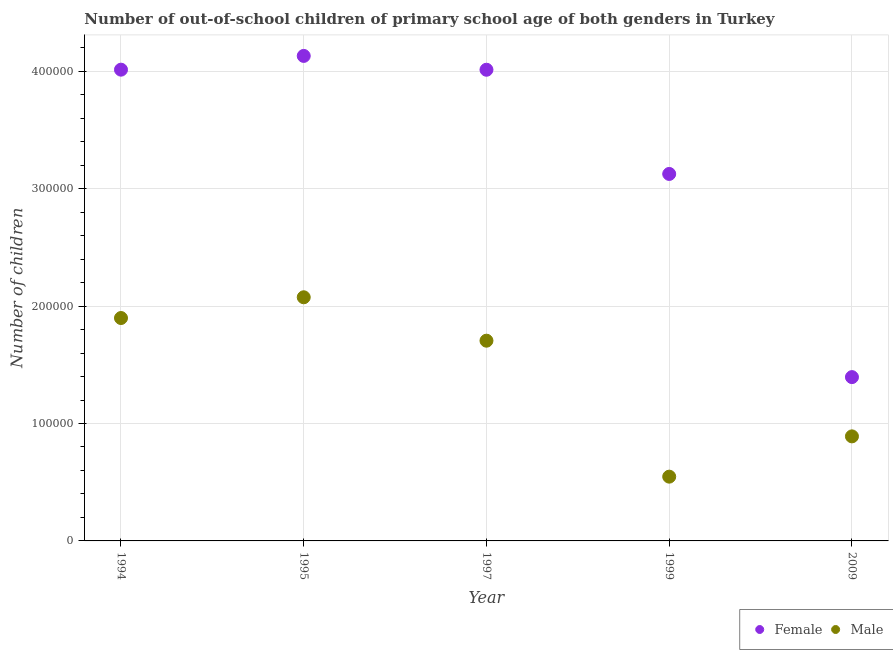Is the number of dotlines equal to the number of legend labels?
Your answer should be compact. Yes. What is the number of male out-of-school students in 1997?
Your answer should be compact. 1.71e+05. Across all years, what is the maximum number of male out-of-school students?
Your answer should be compact. 2.08e+05. Across all years, what is the minimum number of male out-of-school students?
Offer a very short reply. 5.47e+04. In which year was the number of female out-of-school students maximum?
Your answer should be compact. 1995. In which year was the number of female out-of-school students minimum?
Provide a short and direct response. 2009. What is the total number of male out-of-school students in the graph?
Offer a very short reply. 7.12e+05. What is the difference between the number of female out-of-school students in 1994 and that in 1997?
Offer a terse response. 73. What is the difference between the number of female out-of-school students in 1997 and the number of male out-of-school students in 2009?
Your answer should be very brief. 3.12e+05. What is the average number of male out-of-school students per year?
Your answer should be very brief. 1.42e+05. In the year 1997, what is the difference between the number of female out-of-school students and number of male out-of-school students?
Provide a succinct answer. 2.31e+05. In how many years, is the number of male out-of-school students greater than 340000?
Your response must be concise. 0. What is the ratio of the number of male out-of-school students in 1995 to that in 1997?
Ensure brevity in your answer.  1.22. What is the difference between the highest and the second highest number of female out-of-school students?
Provide a short and direct response. 1.17e+04. What is the difference between the highest and the lowest number of male out-of-school students?
Offer a very short reply. 1.53e+05. Is the sum of the number of female out-of-school students in 1995 and 2009 greater than the maximum number of male out-of-school students across all years?
Keep it short and to the point. Yes. Is the number of male out-of-school students strictly greater than the number of female out-of-school students over the years?
Your answer should be very brief. No. How many dotlines are there?
Provide a short and direct response. 2. How many years are there in the graph?
Ensure brevity in your answer.  5. Are the values on the major ticks of Y-axis written in scientific E-notation?
Offer a terse response. No. How are the legend labels stacked?
Your response must be concise. Horizontal. What is the title of the graph?
Make the answer very short. Number of out-of-school children of primary school age of both genders in Turkey. What is the label or title of the X-axis?
Provide a succinct answer. Year. What is the label or title of the Y-axis?
Your answer should be very brief. Number of children. What is the Number of children of Female in 1994?
Your answer should be compact. 4.01e+05. What is the Number of children of Male in 1994?
Provide a succinct answer. 1.90e+05. What is the Number of children in Female in 1995?
Provide a succinct answer. 4.13e+05. What is the Number of children of Male in 1995?
Give a very brief answer. 2.08e+05. What is the Number of children of Female in 1997?
Ensure brevity in your answer.  4.01e+05. What is the Number of children in Male in 1997?
Offer a very short reply. 1.71e+05. What is the Number of children of Female in 1999?
Your answer should be very brief. 3.13e+05. What is the Number of children of Male in 1999?
Offer a very short reply. 5.47e+04. What is the Number of children in Female in 2009?
Your answer should be very brief. 1.40e+05. What is the Number of children in Male in 2009?
Give a very brief answer. 8.90e+04. Across all years, what is the maximum Number of children of Female?
Offer a very short reply. 4.13e+05. Across all years, what is the maximum Number of children of Male?
Provide a short and direct response. 2.08e+05. Across all years, what is the minimum Number of children of Female?
Give a very brief answer. 1.40e+05. Across all years, what is the minimum Number of children in Male?
Give a very brief answer. 5.47e+04. What is the total Number of children of Female in the graph?
Make the answer very short. 1.67e+06. What is the total Number of children in Male in the graph?
Give a very brief answer. 7.12e+05. What is the difference between the Number of children of Female in 1994 and that in 1995?
Provide a short and direct response. -1.17e+04. What is the difference between the Number of children in Male in 1994 and that in 1995?
Provide a short and direct response. -1.77e+04. What is the difference between the Number of children in Male in 1994 and that in 1997?
Your response must be concise. 1.93e+04. What is the difference between the Number of children of Female in 1994 and that in 1999?
Provide a succinct answer. 8.88e+04. What is the difference between the Number of children in Male in 1994 and that in 1999?
Your answer should be very brief. 1.35e+05. What is the difference between the Number of children in Female in 1994 and that in 2009?
Ensure brevity in your answer.  2.62e+05. What is the difference between the Number of children of Male in 1994 and that in 2009?
Your answer should be very brief. 1.01e+05. What is the difference between the Number of children in Female in 1995 and that in 1997?
Provide a short and direct response. 1.18e+04. What is the difference between the Number of children in Male in 1995 and that in 1997?
Your answer should be very brief. 3.70e+04. What is the difference between the Number of children in Female in 1995 and that in 1999?
Your answer should be very brief. 1.01e+05. What is the difference between the Number of children in Male in 1995 and that in 1999?
Provide a short and direct response. 1.53e+05. What is the difference between the Number of children in Female in 1995 and that in 2009?
Offer a very short reply. 2.74e+05. What is the difference between the Number of children in Male in 1995 and that in 2009?
Your answer should be compact. 1.18e+05. What is the difference between the Number of children in Female in 1997 and that in 1999?
Your answer should be very brief. 8.87e+04. What is the difference between the Number of children in Male in 1997 and that in 1999?
Your answer should be very brief. 1.16e+05. What is the difference between the Number of children in Female in 1997 and that in 2009?
Make the answer very short. 2.62e+05. What is the difference between the Number of children of Male in 1997 and that in 2009?
Offer a terse response. 8.15e+04. What is the difference between the Number of children in Female in 1999 and that in 2009?
Offer a terse response. 1.73e+05. What is the difference between the Number of children of Male in 1999 and that in 2009?
Your answer should be very brief. -3.43e+04. What is the difference between the Number of children of Female in 1994 and the Number of children of Male in 1995?
Ensure brevity in your answer.  1.94e+05. What is the difference between the Number of children of Female in 1994 and the Number of children of Male in 1997?
Your answer should be very brief. 2.31e+05. What is the difference between the Number of children of Female in 1994 and the Number of children of Male in 1999?
Ensure brevity in your answer.  3.47e+05. What is the difference between the Number of children of Female in 1994 and the Number of children of Male in 2009?
Your response must be concise. 3.12e+05. What is the difference between the Number of children in Female in 1995 and the Number of children in Male in 1997?
Your response must be concise. 2.43e+05. What is the difference between the Number of children of Female in 1995 and the Number of children of Male in 1999?
Offer a very short reply. 3.58e+05. What is the difference between the Number of children of Female in 1995 and the Number of children of Male in 2009?
Provide a short and direct response. 3.24e+05. What is the difference between the Number of children of Female in 1997 and the Number of children of Male in 1999?
Provide a succinct answer. 3.47e+05. What is the difference between the Number of children of Female in 1997 and the Number of children of Male in 2009?
Provide a succinct answer. 3.12e+05. What is the difference between the Number of children in Female in 1999 and the Number of children in Male in 2009?
Your response must be concise. 2.24e+05. What is the average Number of children in Female per year?
Your answer should be compact. 3.34e+05. What is the average Number of children in Male per year?
Your response must be concise. 1.42e+05. In the year 1994, what is the difference between the Number of children of Female and Number of children of Male?
Your answer should be compact. 2.12e+05. In the year 1995, what is the difference between the Number of children of Female and Number of children of Male?
Give a very brief answer. 2.06e+05. In the year 1997, what is the difference between the Number of children in Female and Number of children in Male?
Provide a succinct answer. 2.31e+05. In the year 1999, what is the difference between the Number of children of Female and Number of children of Male?
Your answer should be very brief. 2.58e+05. In the year 2009, what is the difference between the Number of children in Female and Number of children in Male?
Give a very brief answer. 5.05e+04. What is the ratio of the Number of children of Female in 1994 to that in 1995?
Ensure brevity in your answer.  0.97. What is the ratio of the Number of children in Male in 1994 to that in 1995?
Provide a succinct answer. 0.91. What is the ratio of the Number of children of Male in 1994 to that in 1997?
Your response must be concise. 1.11. What is the ratio of the Number of children of Female in 1994 to that in 1999?
Give a very brief answer. 1.28. What is the ratio of the Number of children in Male in 1994 to that in 1999?
Ensure brevity in your answer.  3.47. What is the ratio of the Number of children of Female in 1994 to that in 2009?
Keep it short and to the point. 2.88. What is the ratio of the Number of children of Male in 1994 to that in 2009?
Ensure brevity in your answer.  2.13. What is the ratio of the Number of children in Female in 1995 to that in 1997?
Your response must be concise. 1.03. What is the ratio of the Number of children in Male in 1995 to that in 1997?
Make the answer very short. 1.22. What is the ratio of the Number of children in Female in 1995 to that in 1999?
Your answer should be very brief. 1.32. What is the ratio of the Number of children of Male in 1995 to that in 1999?
Your answer should be very brief. 3.79. What is the ratio of the Number of children in Female in 1995 to that in 2009?
Offer a terse response. 2.96. What is the ratio of the Number of children in Male in 1995 to that in 2009?
Make the answer very short. 2.33. What is the ratio of the Number of children in Female in 1997 to that in 1999?
Your answer should be very brief. 1.28. What is the ratio of the Number of children of Male in 1997 to that in 1999?
Give a very brief answer. 3.12. What is the ratio of the Number of children of Female in 1997 to that in 2009?
Make the answer very short. 2.88. What is the ratio of the Number of children of Male in 1997 to that in 2009?
Provide a short and direct response. 1.92. What is the ratio of the Number of children of Female in 1999 to that in 2009?
Your answer should be compact. 2.24. What is the ratio of the Number of children in Male in 1999 to that in 2009?
Offer a terse response. 0.61. What is the difference between the highest and the second highest Number of children of Female?
Your answer should be very brief. 1.17e+04. What is the difference between the highest and the second highest Number of children of Male?
Your answer should be compact. 1.77e+04. What is the difference between the highest and the lowest Number of children in Female?
Give a very brief answer. 2.74e+05. What is the difference between the highest and the lowest Number of children of Male?
Make the answer very short. 1.53e+05. 